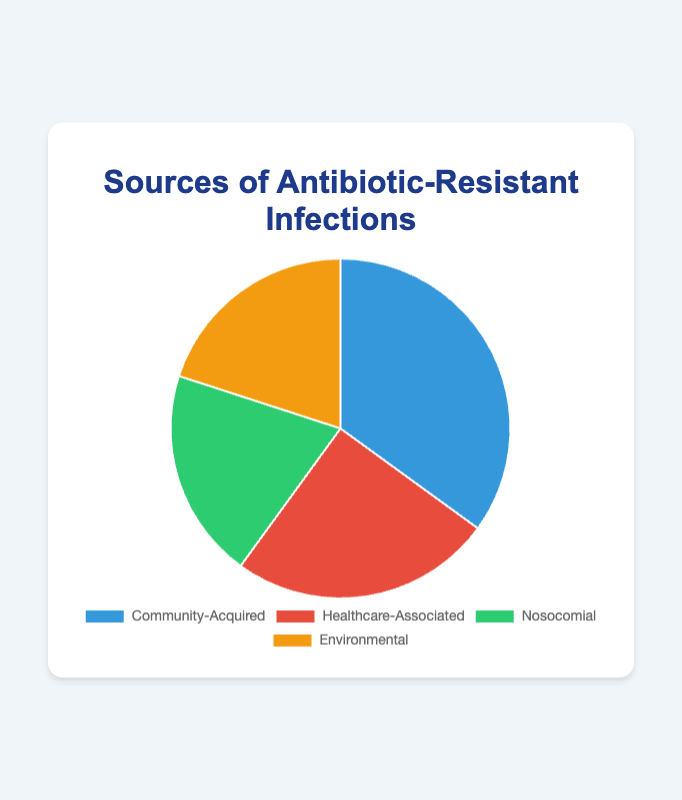What is the most common source of antibiotic-resistant infections? By looking at the pie chart, the largest slice corresponds to the "Community-Acquired" category which makes up 35% of the total.
Answer: Community-Acquired Which two sources have the same percentage of antibiotic-resistant infections, and what is that percentage? The pie chart shows that the "Nosocomial" and "Environmental" categories each have 20%.
Answer: Nosocomial and Environmental, 20% What percentage of antibiotic-resistant infections are healthcare-associated? By referring to the pie chart, the slice labeled "Healthcare-Associated" represents 25% of the total.
Answer: 25% How much greater is the percentage of community-acquired infections compared to nosocomial infections? The community-acquired infections are 35% while the nosocomial infections are 20%. Subtracting these two percentages gives 35% - 20% = 15%.
Answer: 15% What are the combined percentages of healthcare-associated and nosocomial antibiotic-resistant infections? Adding the percentages for healthcare-associated (25%) and nosocomial (20%) gives 25% + 20% = 45%.
Answer: 45% Which source is represented by the green color in the chart? According to the visual attributes of the pie chart, the green slice corresponds to the "Nosocomial" category.
Answer: Nosocomial Is the percentage of environmental infections equal to, less than, or greater than the percentage of healthcare-associated infections? By looking at the pie chart, the percentage of environmental infections (20%) is less than the percentage of healthcare-associated infections (25%).
Answer: Less than What is the sum of the percentages of community-acquired and environmental infections? The community-acquired infections are 35% and the environmental infections are 20%. Adding these two percentages gives 35% + 20% = 55%.
Answer: 55% Which category has the smallest percentage of antibiotic-resistant infections and what color represents it? The pie chart shows that both "Nosocomial" and "Environmental" have the smallest percentage, each with 20%. The environmental category is represented by an orange color.
Answer: Nosocomial and Environmental, Nosocomial is green, Environmental is orange 